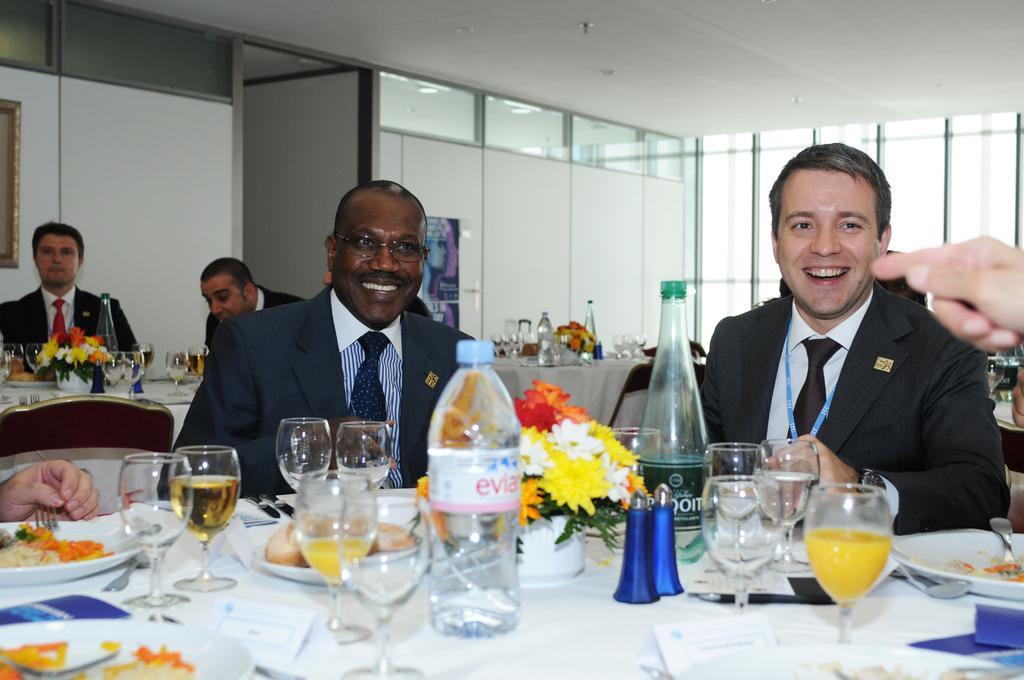In one or two sentences, can you explain what this image depicts? In the image we can see there are people who are sitting on chair and on table there are wine glasses, wine bottle, water bottle and a flower bouquet. 